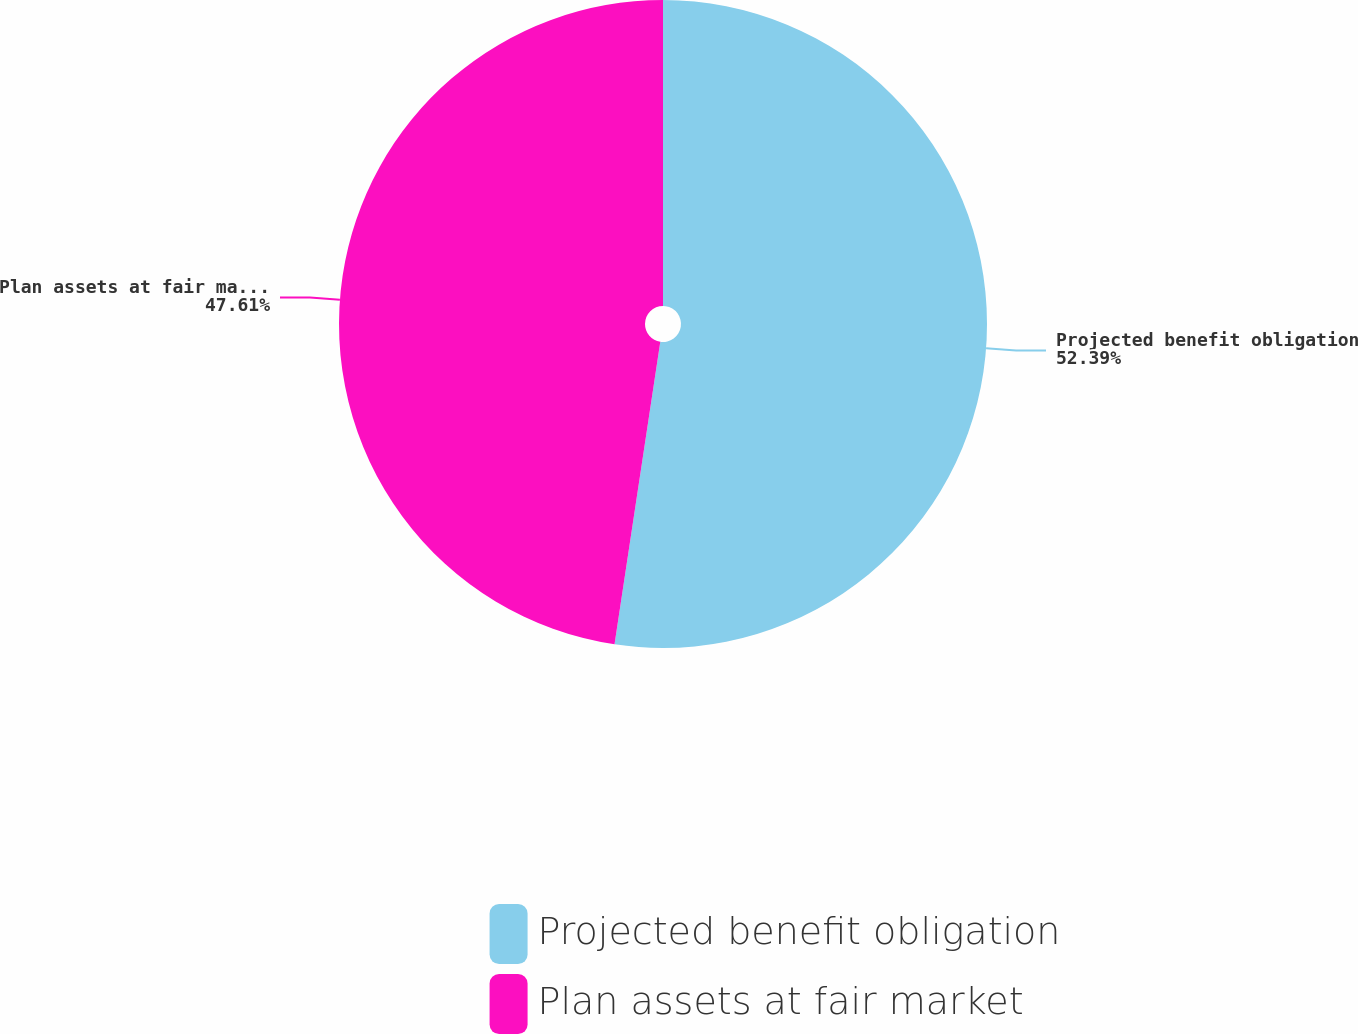Convert chart to OTSL. <chart><loc_0><loc_0><loc_500><loc_500><pie_chart><fcel>Projected benefit obligation<fcel>Plan assets at fair market<nl><fcel>52.39%<fcel>47.61%<nl></chart> 